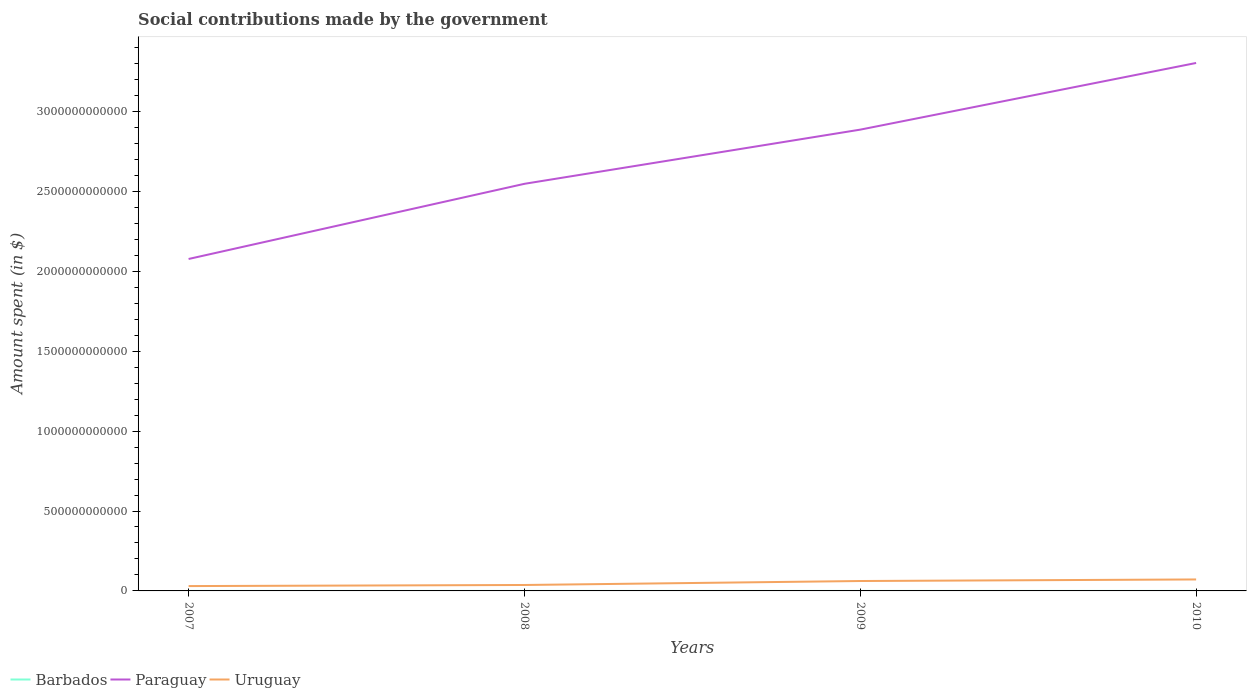Across all years, what is the maximum amount spent on social contributions in Paraguay?
Your response must be concise. 2.08e+12. What is the total amount spent on social contributions in Paraguay in the graph?
Make the answer very short. -7.56e+11. What is the difference between the highest and the second highest amount spent on social contributions in Paraguay?
Provide a succinct answer. 1.23e+12. Is the amount spent on social contributions in Uruguay strictly greater than the amount spent on social contributions in Paraguay over the years?
Your answer should be compact. Yes. What is the difference between two consecutive major ticks on the Y-axis?
Provide a short and direct response. 5.00e+11. Are the values on the major ticks of Y-axis written in scientific E-notation?
Your answer should be compact. No. Does the graph contain any zero values?
Keep it short and to the point. No. Where does the legend appear in the graph?
Offer a very short reply. Bottom left. What is the title of the graph?
Ensure brevity in your answer.  Social contributions made by the government. Does "Sint Maarten (Dutch part)" appear as one of the legend labels in the graph?
Your response must be concise. No. What is the label or title of the X-axis?
Your answer should be compact. Years. What is the label or title of the Y-axis?
Offer a terse response. Amount spent (in $). What is the Amount spent (in $) in Barbados in 2007?
Ensure brevity in your answer.  1.02e+06. What is the Amount spent (in $) of Paraguay in 2007?
Ensure brevity in your answer.  2.08e+12. What is the Amount spent (in $) in Uruguay in 2007?
Your answer should be compact. 3.03e+1. What is the Amount spent (in $) in Barbados in 2008?
Your answer should be compact. 9.49e+05. What is the Amount spent (in $) of Paraguay in 2008?
Offer a very short reply. 2.55e+12. What is the Amount spent (in $) of Uruguay in 2008?
Give a very brief answer. 3.71e+1. What is the Amount spent (in $) of Barbados in 2009?
Your answer should be very brief. 7.55e+05. What is the Amount spent (in $) in Paraguay in 2009?
Offer a terse response. 2.89e+12. What is the Amount spent (in $) in Uruguay in 2009?
Keep it short and to the point. 6.20e+1. What is the Amount spent (in $) in Barbados in 2010?
Offer a very short reply. 7.77e+05. What is the Amount spent (in $) of Paraguay in 2010?
Provide a succinct answer. 3.30e+12. What is the Amount spent (in $) of Uruguay in 2010?
Provide a short and direct response. 7.18e+1. Across all years, what is the maximum Amount spent (in $) of Barbados?
Offer a very short reply. 1.02e+06. Across all years, what is the maximum Amount spent (in $) in Paraguay?
Offer a very short reply. 3.30e+12. Across all years, what is the maximum Amount spent (in $) in Uruguay?
Make the answer very short. 7.18e+1. Across all years, what is the minimum Amount spent (in $) of Barbados?
Your answer should be very brief. 7.55e+05. Across all years, what is the minimum Amount spent (in $) of Paraguay?
Keep it short and to the point. 2.08e+12. Across all years, what is the minimum Amount spent (in $) of Uruguay?
Your answer should be very brief. 3.03e+1. What is the total Amount spent (in $) in Barbados in the graph?
Your response must be concise. 3.50e+06. What is the total Amount spent (in $) in Paraguay in the graph?
Make the answer very short. 1.08e+13. What is the total Amount spent (in $) of Uruguay in the graph?
Your answer should be compact. 2.01e+11. What is the difference between the Amount spent (in $) in Barbados in 2007 and that in 2008?
Your answer should be very brief. 7.40e+04. What is the difference between the Amount spent (in $) of Paraguay in 2007 and that in 2008?
Make the answer very short. -4.70e+11. What is the difference between the Amount spent (in $) in Uruguay in 2007 and that in 2008?
Ensure brevity in your answer.  -6.83e+09. What is the difference between the Amount spent (in $) of Barbados in 2007 and that in 2009?
Offer a very short reply. 2.68e+05. What is the difference between the Amount spent (in $) in Paraguay in 2007 and that in 2009?
Your response must be concise. -8.09e+11. What is the difference between the Amount spent (in $) of Uruguay in 2007 and that in 2009?
Your response must be concise. -3.17e+1. What is the difference between the Amount spent (in $) in Barbados in 2007 and that in 2010?
Your answer should be very brief. 2.46e+05. What is the difference between the Amount spent (in $) in Paraguay in 2007 and that in 2010?
Provide a succinct answer. -1.23e+12. What is the difference between the Amount spent (in $) in Uruguay in 2007 and that in 2010?
Provide a succinct answer. -4.15e+1. What is the difference between the Amount spent (in $) in Barbados in 2008 and that in 2009?
Give a very brief answer. 1.94e+05. What is the difference between the Amount spent (in $) in Paraguay in 2008 and that in 2009?
Keep it short and to the point. -3.39e+11. What is the difference between the Amount spent (in $) in Uruguay in 2008 and that in 2009?
Offer a very short reply. -2.49e+1. What is the difference between the Amount spent (in $) of Barbados in 2008 and that in 2010?
Your answer should be very brief. 1.72e+05. What is the difference between the Amount spent (in $) in Paraguay in 2008 and that in 2010?
Give a very brief answer. -7.56e+11. What is the difference between the Amount spent (in $) in Uruguay in 2008 and that in 2010?
Ensure brevity in your answer.  -3.47e+1. What is the difference between the Amount spent (in $) of Barbados in 2009 and that in 2010?
Offer a terse response. -2.22e+04. What is the difference between the Amount spent (in $) of Paraguay in 2009 and that in 2010?
Your answer should be compact. -4.17e+11. What is the difference between the Amount spent (in $) in Uruguay in 2009 and that in 2010?
Your answer should be compact. -9.80e+09. What is the difference between the Amount spent (in $) of Barbados in 2007 and the Amount spent (in $) of Paraguay in 2008?
Your answer should be compact. -2.55e+12. What is the difference between the Amount spent (in $) in Barbados in 2007 and the Amount spent (in $) in Uruguay in 2008?
Give a very brief answer. -3.71e+1. What is the difference between the Amount spent (in $) of Paraguay in 2007 and the Amount spent (in $) of Uruguay in 2008?
Offer a terse response. 2.04e+12. What is the difference between the Amount spent (in $) of Barbados in 2007 and the Amount spent (in $) of Paraguay in 2009?
Provide a short and direct response. -2.89e+12. What is the difference between the Amount spent (in $) in Barbados in 2007 and the Amount spent (in $) in Uruguay in 2009?
Your response must be concise. -6.20e+1. What is the difference between the Amount spent (in $) of Paraguay in 2007 and the Amount spent (in $) of Uruguay in 2009?
Make the answer very short. 2.02e+12. What is the difference between the Amount spent (in $) of Barbados in 2007 and the Amount spent (in $) of Paraguay in 2010?
Your answer should be very brief. -3.30e+12. What is the difference between the Amount spent (in $) in Barbados in 2007 and the Amount spent (in $) in Uruguay in 2010?
Ensure brevity in your answer.  -7.18e+1. What is the difference between the Amount spent (in $) in Paraguay in 2007 and the Amount spent (in $) in Uruguay in 2010?
Ensure brevity in your answer.  2.01e+12. What is the difference between the Amount spent (in $) in Barbados in 2008 and the Amount spent (in $) in Paraguay in 2009?
Your response must be concise. -2.89e+12. What is the difference between the Amount spent (in $) of Barbados in 2008 and the Amount spent (in $) of Uruguay in 2009?
Offer a very short reply. -6.20e+1. What is the difference between the Amount spent (in $) of Paraguay in 2008 and the Amount spent (in $) of Uruguay in 2009?
Keep it short and to the point. 2.49e+12. What is the difference between the Amount spent (in $) of Barbados in 2008 and the Amount spent (in $) of Paraguay in 2010?
Offer a terse response. -3.30e+12. What is the difference between the Amount spent (in $) in Barbados in 2008 and the Amount spent (in $) in Uruguay in 2010?
Your answer should be compact. -7.18e+1. What is the difference between the Amount spent (in $) of Paraguay in 2008 and the Amount spent (in $) of Uruguay in 2010?
Give a very brief answer. 2.48e+12. What is the difference between the Amount spent (in $) of Barbados in 2009 and the Amount spent (in $) of Paraguay in 2010?
Your answer should be compact. -3.30e+12. What is the difference between the Amount spent (in $) of Barbados in 2009 and the Amount spent (in $) of Uruguay in 2010?
Offer a very short reply. -7.18e+1. What is the difference between the Amount spent (in $) in Paraguay in 2009 and the Amount spent (in $) in Uruguay in 2010?
Keep it short and to the point. 2.81e+12. What is the average Amount spent (in $) in Barbados per year?
Provide a succinct answer. 8.76e+05. What is the average Amount spent (in $) in Paraguay per year?
Ensure brevity in your answer.  2.70e+12. What is the average Amount spent (in $) of Uruguay per year?
Ensure brevity in your answer.  5.03e+1. In the year 2007, what is the difference between the Amount spent (in $) in Barbados and Amount spent (in $) in Paraguay?
Offer a terse response. -2.08e+12. In the year 2007, what is the difference between the Amount spent (in $) of Barbados and Amount spent (in $) of Uruguay?
Provide a short and direct response. -3.03e+1. In the year 2007, what is the difference between the Amount spent (in $) of Paraguay and Amount spent (in $) of Uruguay?
Give a very brief answer. 2.05e+12. In the year 2008, what is the difference between the Amount spent (in $) in Barbados and Amount spent (in $) in Paraguay?
Offer a very short reply. -2.55e+12. In the year 2008, what is the difference between the Amount spent (in $) in Barbados and Amount spent (in $) in Uruguay?
Provide a succinct answer. -3.71e+1. In the year 2008, what is the difference between the Amount spent (in $) of Paraguay and Amount spent (in $) of Uruguay?
Provide a succinct answer. 2.51e+12. In the year 2009, what is the difference between the Amount spent (in $) of Barbados and Amount spent (in $) of Paraguay?
Your answer should be very brief. -2.89e+12. In the year 2009, what is the difference between the Amount spent (in $) in Barbados and Amount spent (in $) in Uruguay?
Your answer should be compact. -6.20e+1. In the year 2009, what is the difference between the Amount spent (in $) of Paraguay and Amount spent (in $) of Uruguay?
Make the answer very short. 2.82e+12. In the year 2010, what is the difference between the Amount spent (in $) of Barbados and Amount spent (in $) of Paraguay?
Offer a very short reply. -3.30e+12. In the year 2010, what is the difference between the Amount spent (in $) in Barbados and Amount spent (in $) in Uruguay?
Your response must be concise. -7.18e+1. In the year 2010, what is the difference between the Amount spent (in $) of Paraguay and Amount spent (in $) of Uruguay?
Your answer should be compact. 3.23e+12. What is the ratio of the Amount spent (in $) in Barbados in 2007 to that in 2008?
Offer a very short reply. 1.08. What is the ratio of the Amount spent (in $) of Paraguay in 2007 to that in 2008?
Keep it short and to the point. 0.82. What is the ratio of the Amount spent (in $) of Uruguay in 2007 to that in 2008?
Your answer should be compact. 0.82. What is the ratio of the Amount spent (in $) of Barbados in 2007 to that in 2009?
Make the answer very short. 1.36. What is the ratio of the Amount spent (in $) of Paraguay in 2007 to that in 2009?
Give a very brief answer. 0.72. What is the ratio of the Amount spent (in $) of Uruguay in 2007 to that in 2009?
Your answer should be very brief. 0.49. What is the ratio of the Amount spent (in $) in Barbados in 2007 to that in 2010?
Provide a succinct answer. 1.32. What is the ratio of the Amount spent (in $) of Paraguay in 2007 to that in 2010?
Ensure brevity in your answer.  0.63. What is the ratio of the Amount spent (in $) of Uruguay in 2007 to that in 2010?
Offer a terse response. 0.42. What is the ratio of the Amount spent (in $) of Barbados in 2008 to that in 2009?
Your response must be concise. 1.26. What is the ratio of the Amount spent (in $) in Paraguay in 2008 to that in 2009?
Ensure brevity in your answer.  0.88. What is the ratio of the Amount spent (in $) in Uruguay in 2008 to that in 2009?
Keep it short and to the point. 0.6. What is the ratio of the Amount spent (in $) in Barbados in 2008 to that in 2010?
Your answer should be compact. 1.22. What is the ratio of the Amount spent (in $) in Paraguay in 2008 to that in 2010?
Your response must be concise. 0.77. What is the ratio of the Amount spent (in $) of Uruguay in 2008 to that in 2010?
Make the answer very short. 0.52. What is the ratio of the Amount spent (in $) in Barbados in 2009 to that in 2010?
Your answer should be compact. 0.97. What is the ratio of the Amount spent (in $) in Paraguay in 2009 to that in 2010?
Keep it short and to the point. 0.87. What is the ratio of the Amount spent (in $) of Uruguay in 2009 to that in 2010?
Make the answer very short. 0.86. What is the difference between the highest and the second highest Amount spent (in $) in Barbados?
Offer a very short reply. 7.40e+04. What is the difference between the highest and the second highest Amount spent (in $) of Paraguay?
Provide a succinct answer. 4.17e+11. What is the difference between the highest and the second highest Amount spent (in $) in Uruguay?
Provide a short and direct response. 9.80e+09. What is the difference between the highest and the lowest Amount spent (in $) in Barbados?
Make the answer very short. 2.68e+05. What is the difference between the highest and the lowest Amount spent (in $) of Paraguay?
Make the answer very short. 1.23e+12. What is the difference between the highest and the lowest Amount spent (in $) of Uruguay?
Offer a very short reply. 4.15e+1. 